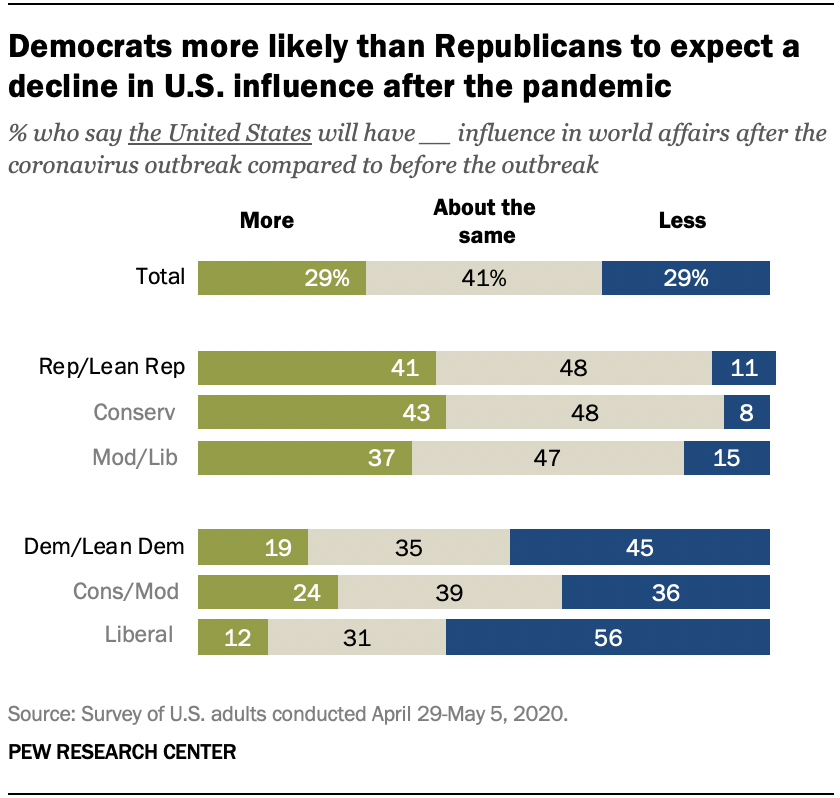List a handful of essential elements in this visual. The olive green color in the graph is indicative of a specific phenomenon or trend. According to the data, approximately 0.01% of people did not answer the survey. 